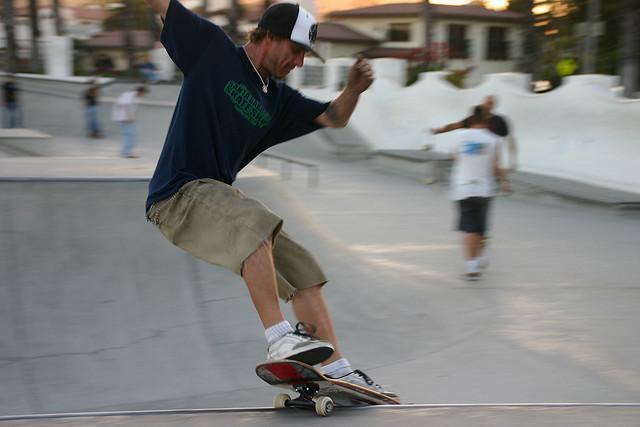How many men are bald in the picture?
Give a very brief answer. 1. How many people are wearing hats?
Give a very brief answer. 1. How many people are there?
Give a very brief answer. 2. 